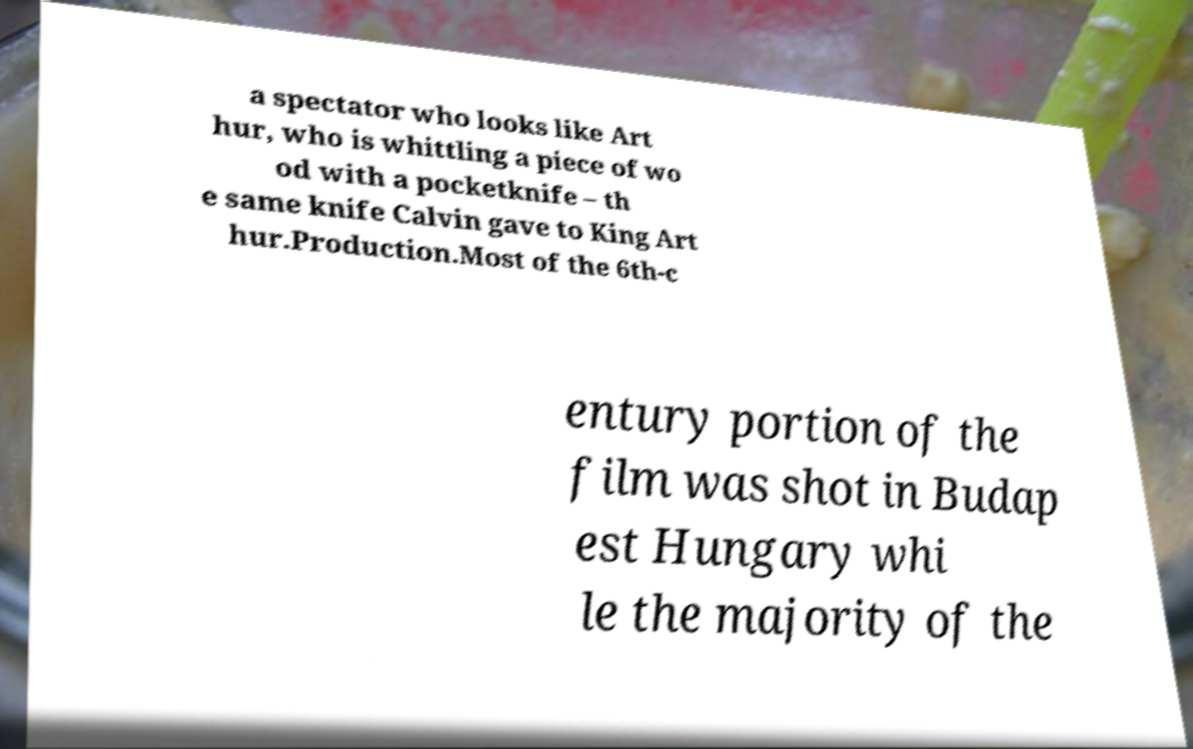For documentation purposes, I need the text within this image transcribed. Could you provide that? a spectator who looks like Art hur, who is whittling a piece of wo od with a pocketknife – th e same knife Calvin gave to King Art hur.Production.Most of the 6th-c entury portion of the film was shot in Budap est Hungary whi le the majority of the 